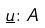Convert formula to latex. <formula><loc_0><loc_0><loc_500><loc_500>\underline { u } \colon A</formula> 